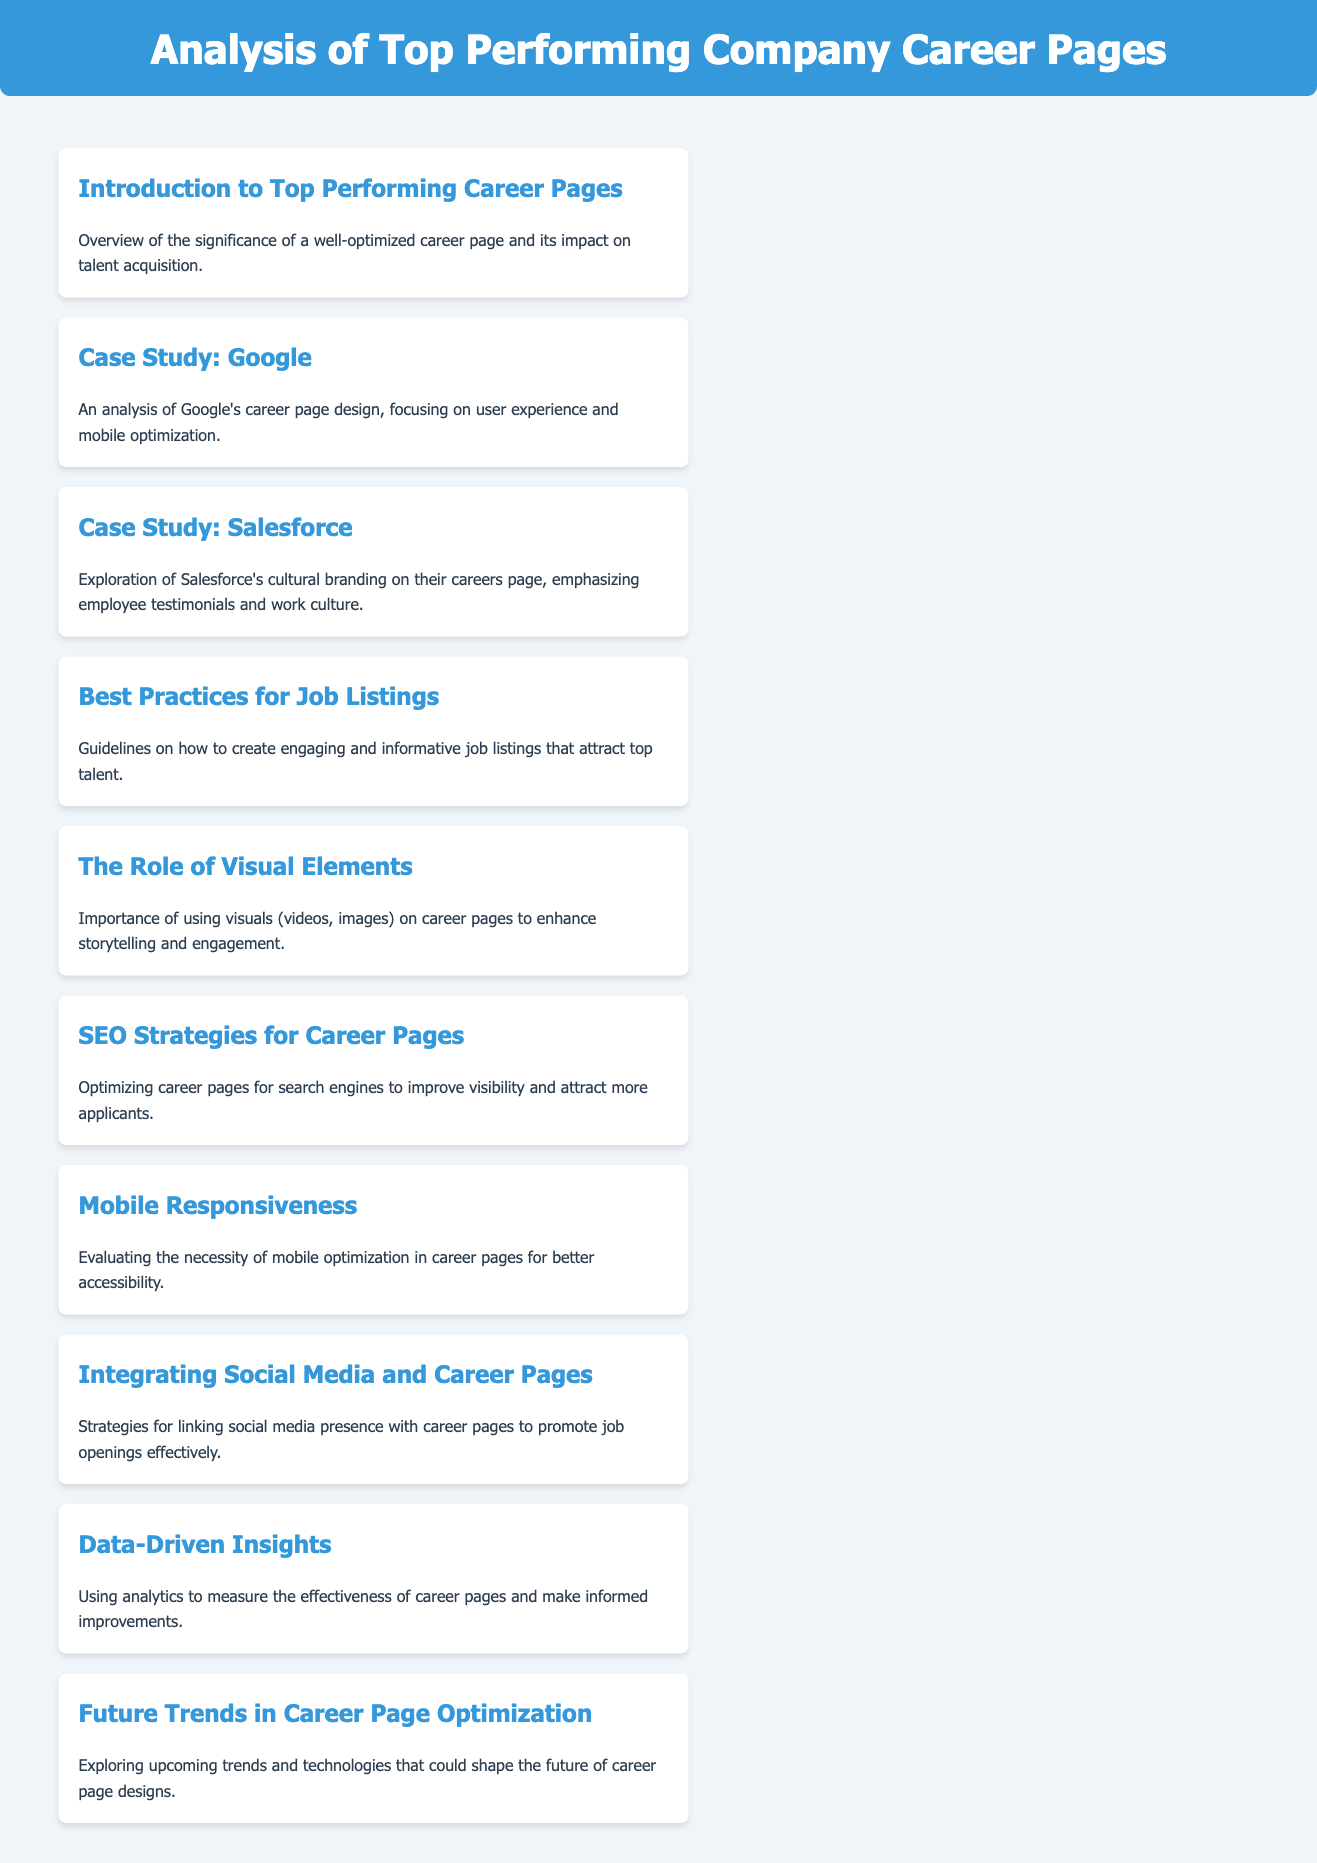what is the title of the document? The title is specified in the `<title>` tag of the HTML document.
Answer: Top Performing Company Career Pages Analysis how many case studies are mentioned? The document lists case studies for specific companies, which can be counted.
Answer: 2 which company is discussed in the case study that focuses on cultural branding? This can be found in the summary of the case studies.
Answer: Salesforce what are the best practices mentioned for job listings? The section title provides insight into the content of that part of the document.
Answer: Guidelines on how to create engaging and informative job listings what is the primary focus of the section on visual elements? The section title and summary indicate what is emphasized.
Answer: Importance of using visuals (videos, images) on career pages how does the document suggest measuring the effectiveness of career pages? The document provides details in the section on data-driven insights.
Answer: Using analytics what is one of the future trends mentioned in the document? This can be inferred from the title of the last section.
Answer: Exploring upcoming trends and technologies how are social media strategies related to career pages? The document suggests linking social media presence with career pages.
Answer: To promote job openings effectively why is mobile responsiveness discussed in the document? The section title indicates the main reason for discussing this topic.
Answer: Better accessibility 